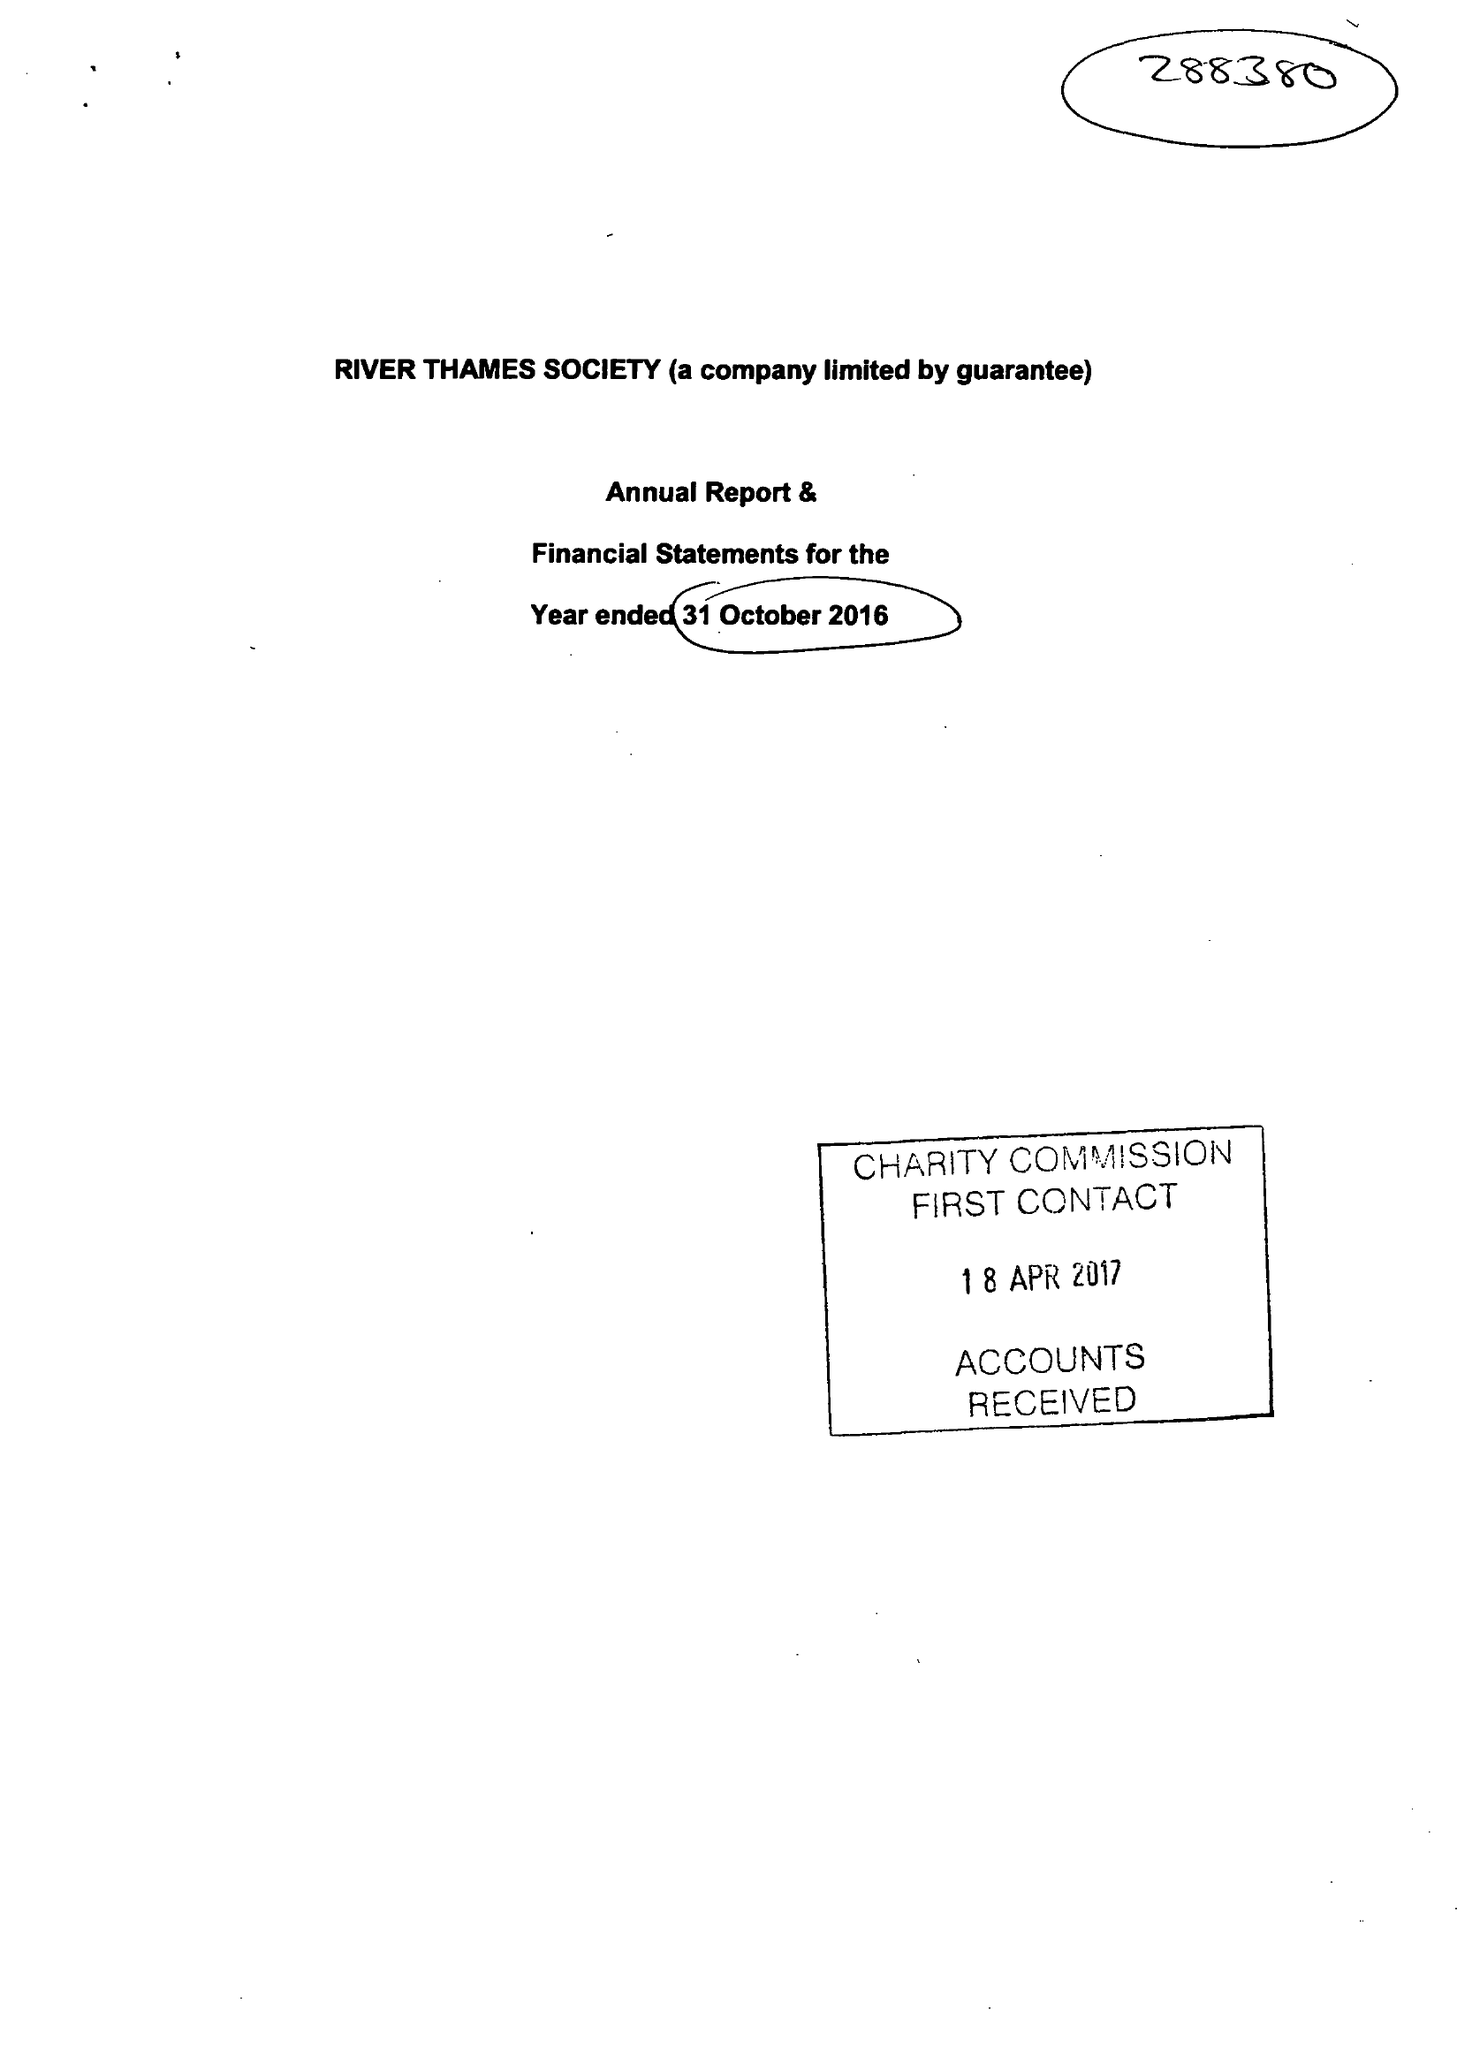What is the value for the address__street_line?
Answer the question using a single word or phrase. 28 BEAUMONT ROAD 